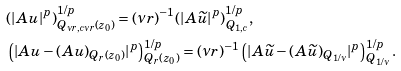<formula> <loc_0><loc_0><loc_500><loc_500>& ( | A u | ^ { p } ) ^ { 1 / p } _ { Q _ { \nu r , c \nu r } ( z _ { 0 } ) } = ( \nu r ) ^ { - 1 } ( | A \widetilde { u } | ^ { p } ) ^ { 1 / p } _ { Q _ { 1 , c } } , \\ & \left ( | A u - ( A u ) _ { Q _ { r } ( z _ { 0 } ) } | ^ { p } \right ) ^ { 1 / p } _ { Q _ { r } ( z _ { 0 } ) } = ( \nu r ) ^ { - 1 } \left ( | A \widetilde { u } - ( A \widetilde { u } ) _ { Q _ { 1 / \nu } } | ^ { p } \right ) _ { Q _ { 1 / \nu } } ^ { 1 / p } .</formula> 